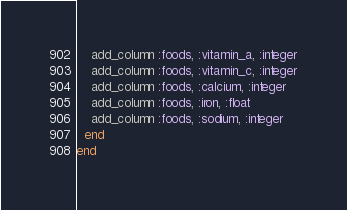Convert code to text. <code><loc_0><loc_0><loc_500><loc_500><_Ruby_>    add_column :foods, :vitamin_a, :integer
    add_column :foods, :vitamin_c, :integer
    add_column :foods, :calcium, :integer
    add_column :foods, :iron, :float
    add_column :foods, :sodium, :integer
  end
end
</code> 